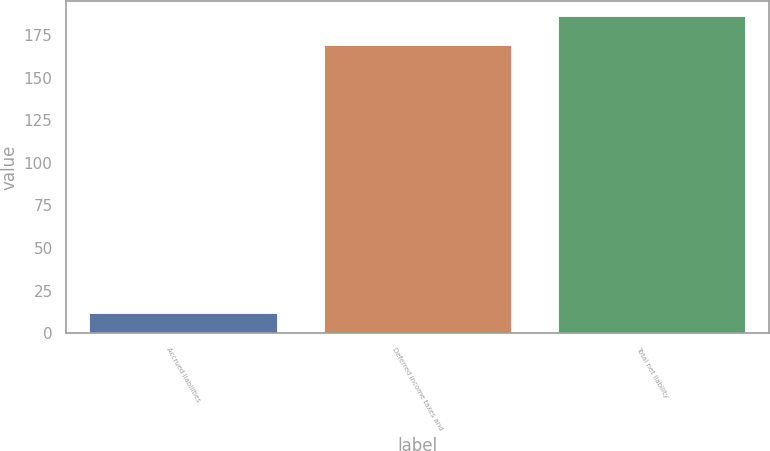Convert chart to OTSL. <chart><loc_0><loc_0><loc_500><loc_500><bar_chart><fcel>Accrued liabilities<fcel>Deferred income taxes and<fcel>Total net liability<nl><fcel>12<fcel>169<fcel>185.9<nl></chart> 